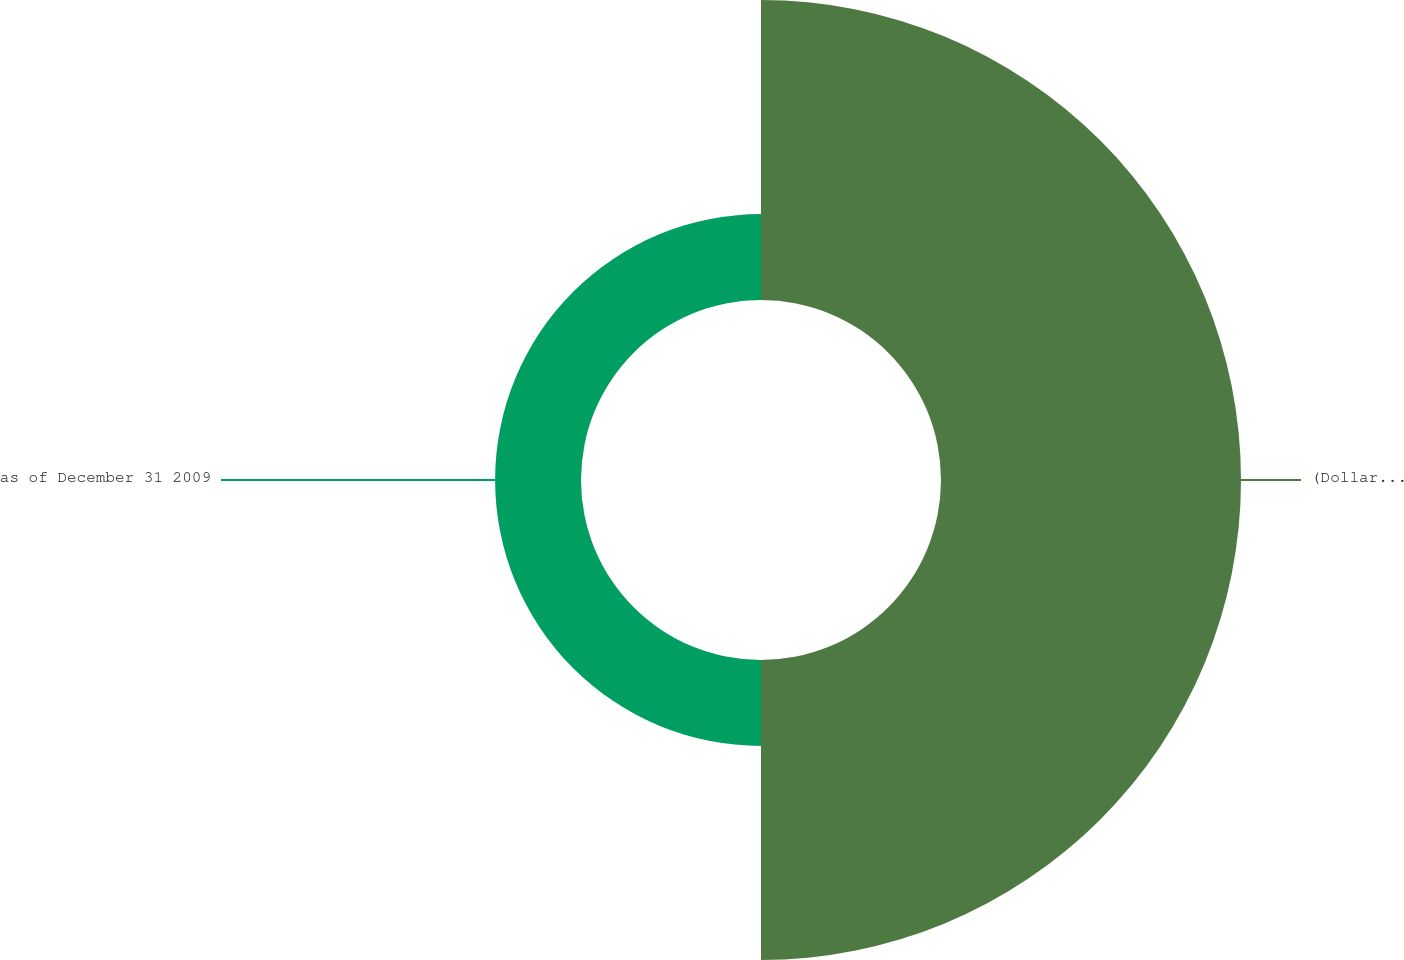Convert chart to OTSL. <chart><loc_0><loc_0><loc_500><loc_500><pie_chart><fcel>(Dollars in millions) Accident<fcel>as of December 31 2009<nl><fcel>77.74%<fcel>22.26%<nl></chart> 